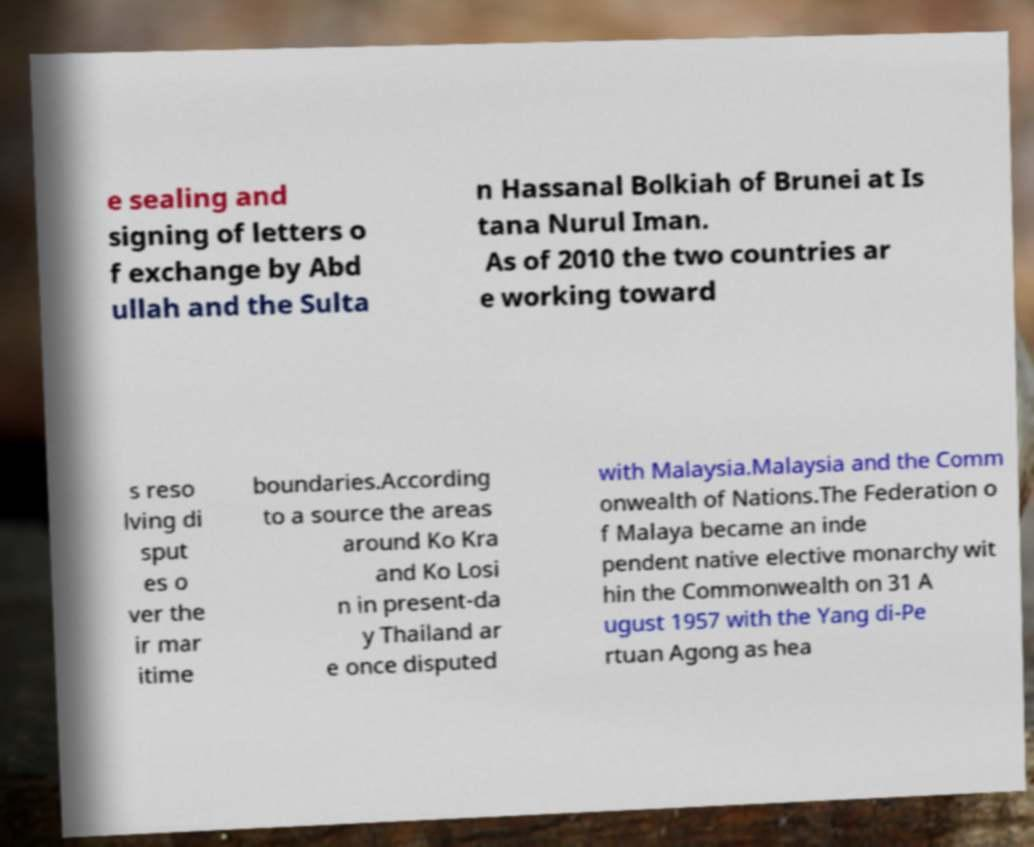For documentation purposes, I need the text within this image transcribed. Could you provide that? e sealing and signing of letters o f exchange by Abd ullah and the Sulta n Hassanal Bolkiah of Brunei at Is tana Nurul Iman. As of 2010 the two countries ar e working toward s reso lving di sput es o ver the ir mar itime boundaries.According to a source the areas around Ko Kra and Ko Losi n in present-da y Thailand ar e once disputed with Malaysia.Malaysia and the Comm onwealth of Nations.The Federation o f Malaya became an inde pendent native elective monarchy wit hin the Commonwealth on 31 A ugust 1957 with the Yang di-Pe rtuan Agong as hea 